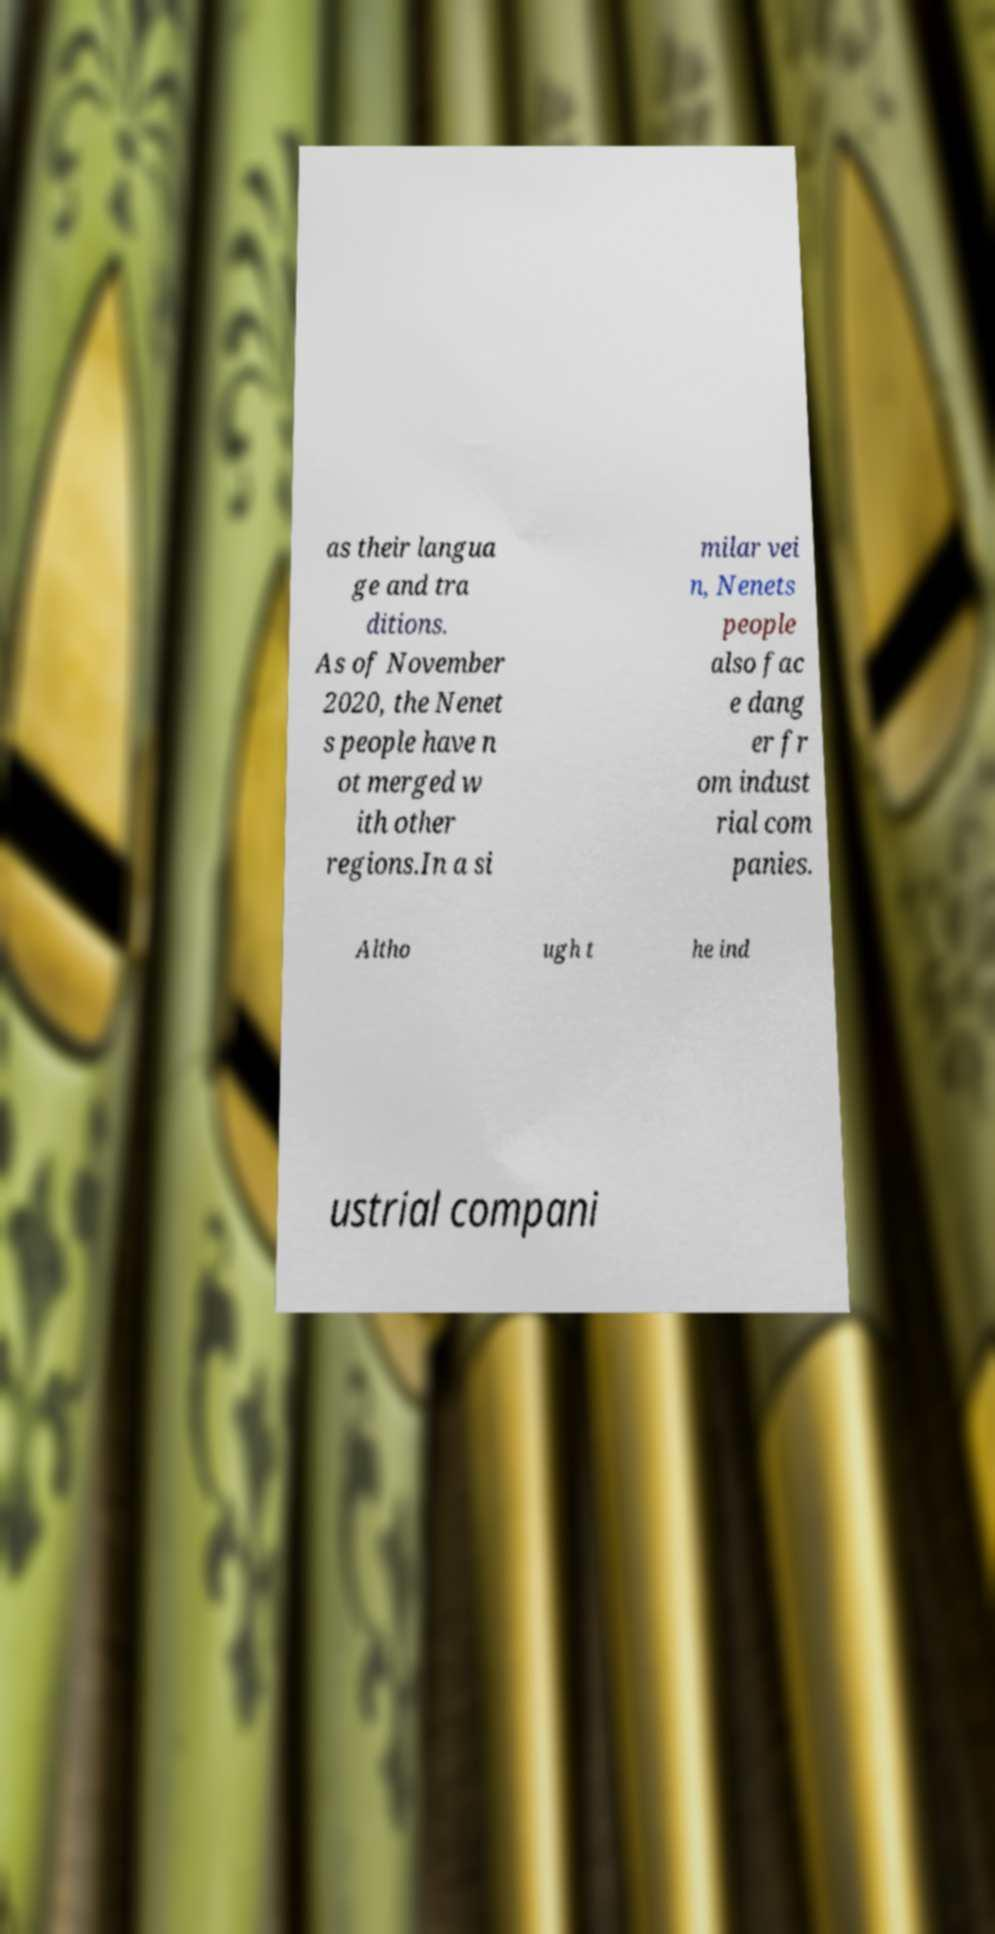Could you extract and type out the text from this image? as their langua ge and tra ditions. As of November 2020, the Nenet s people have n ot merged w ith other regions.In a si milar vei n, Nenets people also fac e dang er fr om indust rial com panies. Altho ugh t he ind ustrial compani 